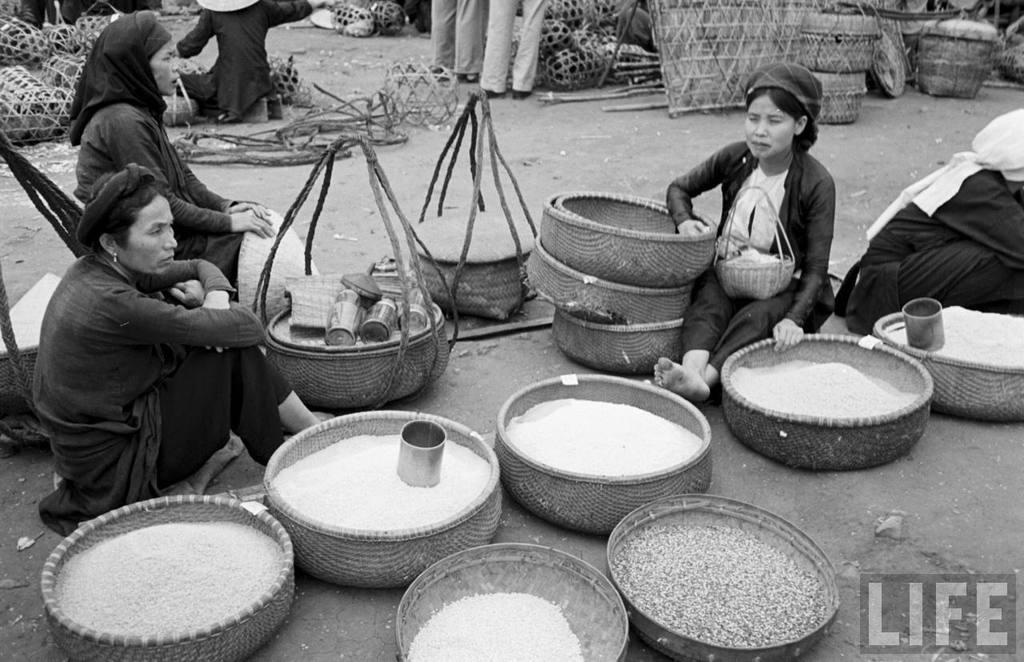What are the women in the image doing? The women in the image are sitting on the floor. What objects do the women have with them? The women have baskets with them. What is inside the baskets? There are food grains in the baskets. What arithmetic problem is the woman solving in the image? There is no arithmetic problem visible in the image. How many trees are present in the image? There are no trees present in the image. 